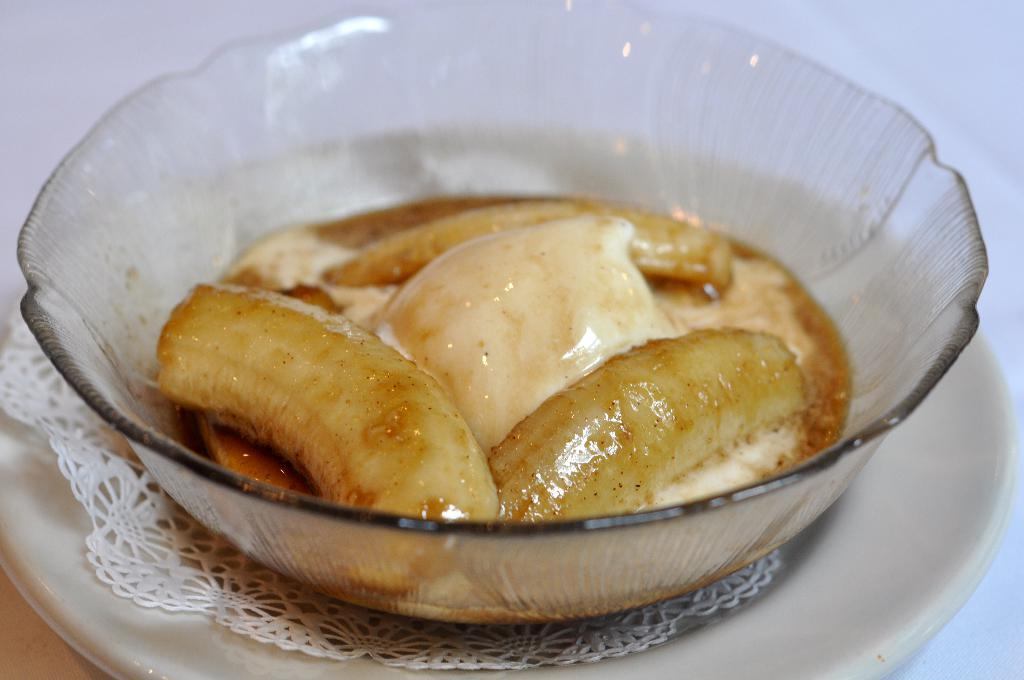What is in the bowl that is visible in the image? There is a bowl with food in the image. What other item can be seen on the surface in the image? There is a plate on the surface in the image. What color is the background of the image? The background of the image is white. How many kittens are playing during the holiday in the image? There are no kittens or holidays mentioned in the image; it only features a bowl with food and a plate on a white background. 